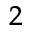<formula> <loc_0><loc_0><loc_500><loc_500>_ { 2 }</formula> 